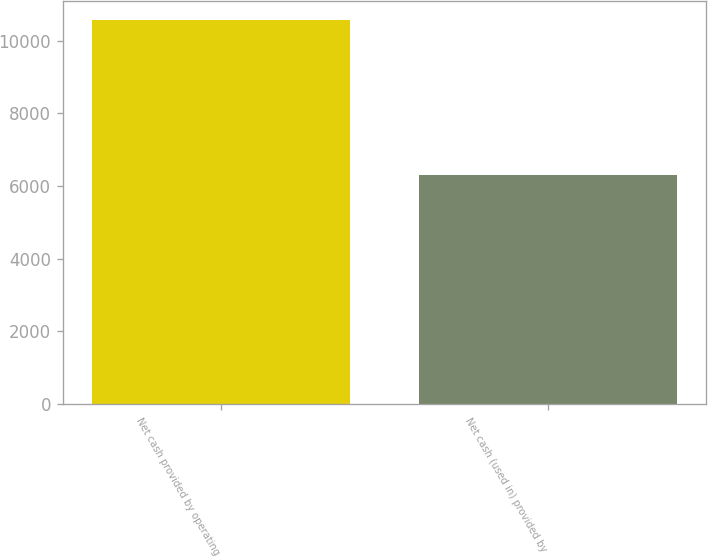Convert chart to OTSL. <chart><loc_0><loc_0><loc_500><loc_500><bar_chart><fcel>Net cash provided by operating<fcel>Net cash (used in) provided by<nl><fcel>10572<fcel>6313<nl></chart> 